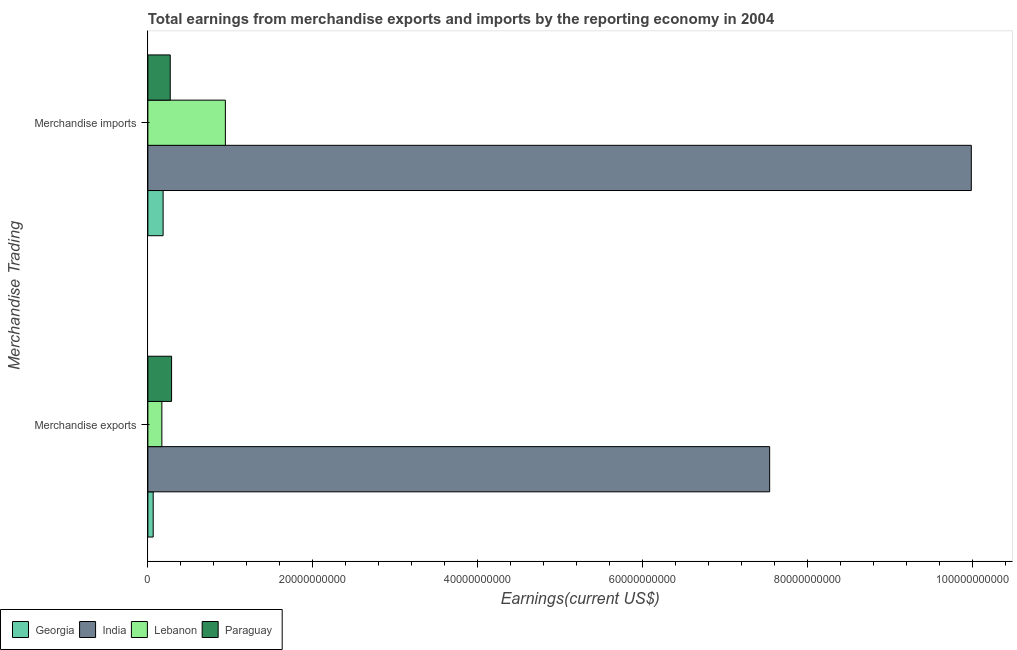How many groups of bars are there?
Provide a short and direct response. 2. Are the number of bars per tick equal to the number of legend labels?
Your answer should be compact. Yes. How many bars are there on the 2nd tick from the top?
Your answer should be very brief. 4. How many bars are there on the 1st tick from the bottom?
Provide a short and direct response. 4. What is the label of the 2nd group of bars from the top?
Make the answer very short. Merchandise exports. What is the earnings from merchandise imports in Georgia?
Offer a very short reply. 1.85e+09. Across all countries, what is the maximum earnings from merchandise imports?
Your response must be concise. 9.98e+1. Across all countries, what is the minimum earnings from merchandise exports?
Provide a succinct answer. 6.45e+08. In which country was the earnings from merchandise exports maximum?
Provide a short and direct response. India. In which country was the earnings from merchandise exports minimum?
Ensure brevity in your answer.  Georgia. What is the total earnings from merchandise exports in the graph?
Give a very brief answer. 8.06e+1. What is the difference between the earnings from merchandise imports in India and that in Georgia?
Give a very brief answer. 9.80e+1. What is the difference between the earnings from merchandise exports in Georgia and the earnings from merchandise imports in Lebanon?
Keep it short and to the point. -8.75e+09. What is the average earnings from merchandise exports per country?
Provide a short and direct response. 2.02e+1. What is the difference between the earnings from merchandise exports and earnings from merchandise imports in Georgia?
Provide a short and direct response. -1.20e+09. In how many countries, is the earnings from merchandise exports greater than 28000000000 US$?
Offer a terse response. 1. What is the ratio of the earnings from merchandise imports in Paraguay to that in Georgia?
Offer a terse response. 1.47. What does the 1st bar from the top in Merchandise imports represents?
Your answer should be compact. Paraguay. What does the 2nd bar from the bottom in Merchandise imports represents?
Your response must be concise. India. Are all the bars in the graph horizontal?
Offer a terse response. Yes. What is the difference between two consecutive major ticks on the X-axis?
Provide a succinct answer. 2.00e+1. Are the values on the major ticks of X-axis written in scientific E-notation?
Ensure brevity in your answer.  No. Does the graph contain any zero values?
Offer a terse response. No. How many legend labels are there?
Provide a short and direct response. 4. How are the legend labels stacked?
Your answer should be very brief. Horizontal. What is the title of the graph?
Your response must be concise. Total earnings from merchandise exports and imports by the reporting economy in 2004. What is the label or title of the X-axis?
Provide a short and direct response. Earnings(current US$). What is the label or title of the Y-axis?
Provide a succinct answer. Merchandise Trading. What is the Earnings(current US$) of Georgia in Merchandise exports?
Your answer should be compact. 6.45e+08. What is the Earnings(current US$) of India in Merchandise exports?
Give a very brief answer. 7.54e+1. What is the Earnings(current US$) of Lebanon in Merchandise exports?
Make the answer very short. 1.70e+09. What is the Earnings(current US$) of Paraguay in Merchandise exports?
Ensure brevity in your answer.  2.87e+09. What is the Earnings(current US$) of Georgia in Merchandise imports?
Your answer should be very brief. 1.85e+09. What is the Earnings(current US$) of India in Merchandise imports?
Make the answer very short. 9.98e+1. What is the Earnings(current US$) in Lebanon in Merchandise imports?
Your response must be concise. 9.40e+09. What is the Earnings(current US$) in Paraguay in Merchandise imports?
Your answer should be compact. 2.71e+09. Across all Merchandise Trading, what is the maximum Earnings(current US$) in Georgia?
Offer a very short reply. 1.85e+09. Across all Merchandise Trading, what is the maximum Earnings(current US$) in India?
Your response must be concise. 9.98e+1. Across all Merchandise Trading, what is the maximum Earnings(current US$) in Lebanon?
Provide a succinct answer. 9.40e+09. Across all Merchandise Trading, what is the maximum Earnings(current US$) of Paraguay?
Your answer should be compact. 2.87e+09. Across all Merchandise Trading, what is the minimum Earnings(current US$) in Georgia?
Offer a terse response. 6.45e+08. Across all Merchandise Trading, what is the minimum Earnings(current US$) of India?
Offer a very short reply. 7.54e+1. Across all Merchandise Trading, what is the minimum Earnings(current US$) in Lebanon?
Provide a short and direct response. 1.70e+09. Across all Merchandise Trading, what is the minimum Earnings(current US$) of Paraguay?
Your response must be concise. 2.71e+09. What is the total Earnings(current US$) of Georgia in the graph?
Keep it short and to the point. 2.49e+09. What is the total Earnings(current US$) in India in the graph?
Your answer should be very brief. 1.75e+11. What is the total Earnings(current US$) of Lebanon in the graph?
Make the answer very short. 1.11e+1. What is the total Earnings(current US$) in Paraguay in the graph?
Provide a succinct answer. 5.59e+09. What is the difference between the Earnings(current US$) of Georgia in Merchandise exports and that in Merchandise imports?
Provide a short and direct response. -1.20e+09. What is the difference between the Earnings(current US$) of India in Merchandise exports and that in Merchandise imports?
Offer a very short reply. -2.45e+1. What is the difference between the Earnings(current US$) of Lebanon in Merchandise exports and that in Merchandise imports?
Give a very brief answer. -7.70e+09. What is the difference between the Earnings(current US$) of Paraguay in Merchandise exports and that in Merchandise imports?
Make the answer very short. 1.63e+08. What is the difference between the Earnings(current US$) of Georgia in Merchandise exports and the Earnings(current US$) of India in Merchandise imports?
Your answer should be compact. -9.92e+1. What is the difference between the Earnings(current US$) in Georgia in Merchandise exports and the Earnings(current US$) in Lebanon in Merchandise imports?
Ensure brevity in your answer.  -8.75e+09. What is the difference between the Earnings(current US$) of Georgia in Merchandise exports and the Earnings(current US$) of Paraguay in Merchandise imports?
Make the answer very short. -2.07e+09. What is the difference between the Earnings(current US$) of India in Merchandise exports and the Earnings(current US$) of Lebanon in Merchandise imports?
Provide a short and direct response. 6.60e+1. What is the difference between the Earnings(current US$) in India in Merchandise exports and the Earnings(current US$) in Paraguay in Merchandise imports?
Make the answer very short. 7.27e+1. What is the difference between the Earnings(current US$) in Lebanon in Merchandise exports and the Earnings(current US$) in Paraguay in Merchandise imports?
Provide a succinct answer. -1.01e+09. What is the average Earnings(current US$) in Georgia per Merchandise Trading?
Your answer should be very brief. 1.25e+09. What is the average Earnings(current US$) of India per Merchandise Trading?
Your answer should be very brief. 8.76e+1. What is the average Earnings(current US$) in Lebanon per Merchandise Trading?
Your answer should be compact. 5.55e+09. What is the average Earnings(current US$) of Paraguay per Merchandise Trading?
Offer a terse response. 2.79e+09. What is the difference between the Earnings(current US$) of Georgia and Earnings(current US$) of India in Merchandise exports?
Give a very brief answer. -7.47e+1. What is the difference between the Earnings(current US$) of Georgia and Earnings(current US$) of Lebanon in Merchandise exports?
Your response must be concise. -1.05e+09. What is the difference between the Earnings(current US$) of Georgia and Earnings(current US$) of Paraguay in Merchandise exports?
Your answer should be very brief. -2.23e+09. What is the difference between the Earnings(current US$) of India and Earnings(current US$) of Lebanon in Merchandise exports?
Offer a very short reply. 7.37e+1. What is the difference between the Earnings(current US$) of India and Earnings(current US$) of Paraguay in Merchandise exports?
Make the answer very short. 7.25e+1. What is the difference between the Earnings(current US$) of Lebanon and Earnings(current US$) of Paraguay in Merchandise exports?
Provide a succinct answer. -1.18e+09. What is the difference between the Earnings(current US$) of Georgia and Earnings(current US$) of India in Merchandise imports?
Offer a very short reply. -9.80e+1. What is the difference between the Earnings(current US$) of Georgia and Earnings(current US$) of Lebanon in Merchandise imports?
Offer a very short reply. -7.55e+09. What is the difference between the Earnings(current US$) in Georgia and Earnings(current US$) in Paraguay in Merchandise imports?
Keep it short and to the point. -8.64e+08. What is the difference between the Earnings(current US$) of India and Earnings(current US$) of Lebanon in Merchandise imports?
Make the answer very short. 9.04e+1. What is the difference between the Earnings(current US$) in India and Earnings(current US$) in Paraguay in Merchandise imports?
Make the answer very short. 9.71e+1. What is the difference between the Earnings(current US$) in Lebanon and Earnings(current US$) in Paraguay in Merchandise imports?
Give a very brief answer. 6.69e+09. What is the ratio of the Earnings(current US$) in Georgia in Merchandise exports to that in Merchandise imports?
Make the answer very short. 0.35. What is the ratio of the Earnings(current US$) in India in Merchandise exports to that in Merchandise imports?
Offer a terse response. 0.76. What is the ratio of the Earnings(current US$) in Lebanon in Merchandise exports to that in Merchandise imports?
Your answer should be very brief. 0.18. What is the ratio of the Earnings(current US$) in Paraguay in Merchandise exports to that in Merchandise imports?
Provide a succinct answer. 1.06. What is the difference between the highest and the second highest Earnings(current US$) in Georgia?
Provide a short and direct response. 1.20e+09. What is the difference between the highest and the second highest Earnings(current US$) of India?
Your answer should be compact. 2.45e+1. What is the difference between the highest and the second highest Earnings(current US$) in Lebanon?
Provide a succinct answer. 7.70e+09. What is the difference between the highest and the second highest Earnings(current US$) in Paraguay?
Provide a short and direct response. 1.63e+08. What is the difference between the highest and the lowest Earnings(current US$) of Georgia?
Ensure brevity in your answer.  1.20e+09. What is the difference between the highest and the lowest Earnings(current US$) in India?
Offer a terse response. 2.45e+1. What is the difference between the highest and the lowest Earnings(current US$) in Lebanon?
Your answer should be compact. 7.70e+09. What is the difference between the highest and the lowest Earnings(current US$) in Paraguay?
Give a very brief answer. 1.63e+08. 